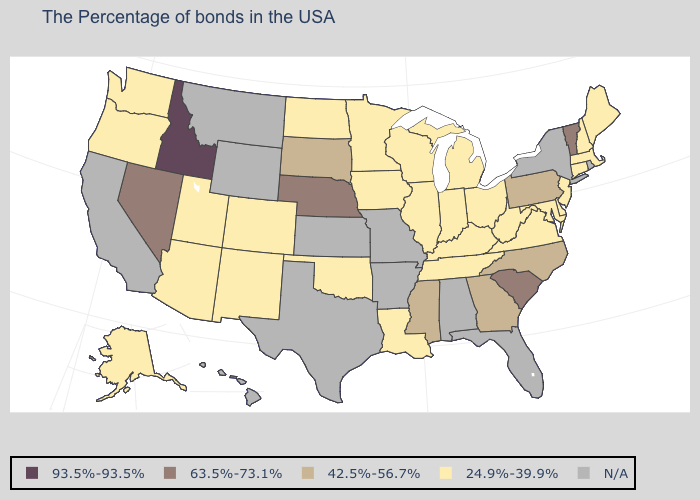Does the first symbol in the legend represent the smallest category?
Be succinct. No. What is the value of Georgia?
Concise answer only. 42.5%-56.7%. Is the legend a continuous bar?
Write a very short answer. No. Among the states that border Vermont , which have the lowest value?
Short answer required. Massachusetts, New Hampshire. Name the states that have a value in the range N/A?
Answer briefly. Rhode Island, New York, Florida, Alabama, Missouri, Arkansas, Kansas, Texas, Wyoming, Montana, California, Hawaii. Among the states that border North Carolina , does Georgia have the lowest value?
Keep it brief. No. Which states hav the highest value in the Northeast?
Give a very brief answer. Vermont. What is the value of New Hampshire?
Keep it brief. 24.9%-39.9%. What is the highest value in the West ?
Concise answer only. 93.5%-93.5%. What is the value of North Carolina?
Write a very short answer. 42.5%-56.7%. What is the highest value in the South ?
Write a very short answer. 63.5%-73.1%. Does New Jersey have the lowest value in the USA?
Be succinct. Yes. What is the value of Michigan?
Answer briefly. 24.9%-39.9%. 